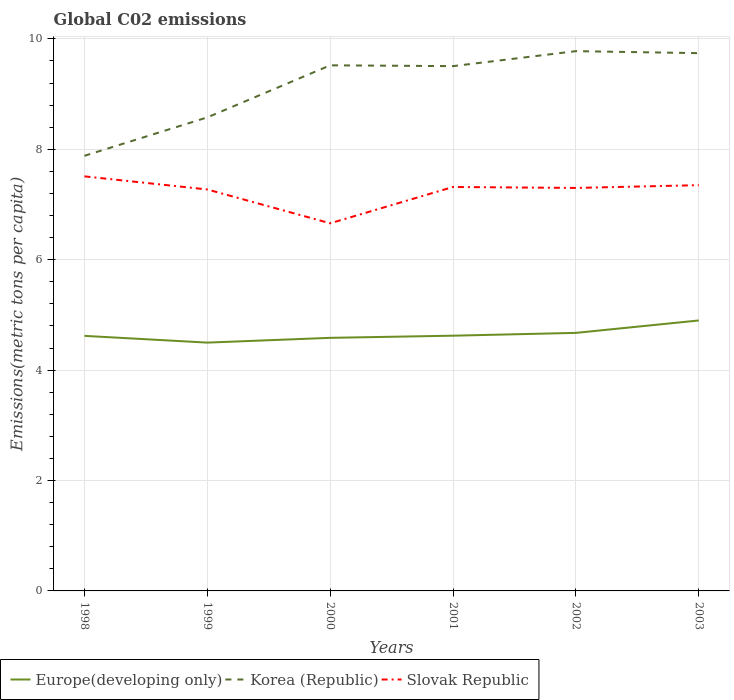Is the number of lines equal to the number of legend labels?
Keep it short and to the point. Yes. Across all years, what is the maximum amount of CO2 emitted in in Korea (Republic)?
Your answer should be compact. 7.88. What is the total amount of CO2 emitted in in Korea (Republic) in the graph?
Make the answer very short. -1.2. What is the difference between the highest and the second highest amount of CO2 emitted in in Slovak Republic?
Offer a very short reply. 0.85. Is the amount of CO2 emitted in in Slovak Republic strictly greater than the amount of CO2 emitted in in Europe(developing only) over the years?
Your response must be concise. No. How many lines are there?
Your answer should be very brief. 3. Where does the legend appear in the graph?
Make the answer very short. Bottom left. How are the legend labels stacked?
Keep it short and to the point. Horizontal. What is the title of the graph?
Provide a short and direct response. Global C02 emissions. Does "St. Martin (French part)" appear as one of the legend labels in the graph?
Offer a terse response. No. What is the label or title of the X-axis?
Offer a terse response. Years. What is the label or title of the Y-axis?
Your answer should be very brief. Emissions(metric tons per capita). What is the Emissions(metric tons per capita) of Europe(developing only) in 1998?
Give a very brief answer. 4.62. What is the Emissions(metric tons per capita) of Korea (Republic) in 1998?
Provide a short and direct response. 7.88. What is the Emissions(metric tons per capita) of Slovak Republic in 1998?
Offer a terse response. 7.51. What is the Emissions(metric tons per capita) in Europe(developing only) in 1999?
Offer a very short reply. 4.5. What is the Emissions(metric tons per capita) in Korea (Republic) in 1999?
Your answer should be compact. 8.58. What is the Emissions(metric tons per capita) of Slovak Republic in 1999?
Your answer should be very brief. 7.27. What is the Emissions(metric tons per capita) of Europe(developing only) in 2000?
Ensure brevity in your answer.  4.58. What is the Emissions(metric tons per capita) in Korea (Republic) in 2000?
Your answer should be compact. 9.52. What is the Emissions(metric tons per capita) in Slovak Republic in 2000?
Ensure brevity in your answer.  6.66. What is the Emissions(metric tons per capita) in Europe(developing only) in 2001?
Provide a short and direct response. 4.62. What is the Emissions(metric tons per capita) of Korea (Republic) in 2001?
Give a very brief answer. 9.51. What is the Emissions(metric tons per capita) in Slovak Republic in 2001?
Make the answer very short. 7.32. What is the Emissions(metric tons per capita) of Europe(developing only) in 2002?
Keep it short and to the point. 4.67. What is the Emissions(metric tons per capita) of Korea (Republic) in 2002?
Make the answer very short. 9.78. What is the Emissions(metric tons per capita) in Slovak Republic in 2002?
Give a very brief answer. 7.3. What is the Emissions(metric tons per capita) of Europe(developing only) in 2003?
Offer a terse response. 4.9. What is the Emissions(metric tons per capita) of Korea (Republic) in 2003?
Offer a very short reply. 9.74. What is the Emissions(metric tons per capita) of Slovak Republic in 2003?
Offer a very short reply. 7.35. Across all years, what is the maximum Emissions(metric tons per capita) of Europe(developing only)?
Your response must be concise. 4.9. Across all years, what is the maximum Emissions(metric tons per capita) in Korea (Republic)?
Your answer should be very brief. 9.78. Across all years, what is the maximum Emissions(metric tons per capita) in Slovak Republic?
Provide a short and direct response. 7.51. Across all years, what is the minimum Emissions(metric tons per capita) in Europe(developing only)?
Offer a very short reply. 4.5. Across all years, what is the minimum Emissions(metric tons per capita) in Korea (Republic)?
Provide a succinct answer. 7.88. Across all years, what is the minimum Emissions(metric tons per capita) in Slovak Republic?
Give a very brief answer. 6.66. What is the total Emissions(metric tons per capita) in Europe(developing only) in the graph?
Offer a terse response. 27.9. What is the total Emissions(metric tons per capita) of Korea (Republic) in the graph?
Your answer should be very brief. 55.01. What is the total Emissions(metric tons per capita) of Slovak Republic in the graph?
Keep it short and to the point. 43.41. What is the difference between the Emissions(metric tons per capita) in Europe(developing only) in 1998 and that in 1999?
Give a very brief answer. 0.12. What is the difference between the Emissions(metric tons per capita) in Korea (Republic) in 1998 and that in 1999?
Your answer should be very brief. -0.7. What is the difference between the Emissions(metric tons per capita) in Slovak Republic in 1998 and that in 1999?
Provide a short and direct response. 0.24. What is the difference between the Emissions(metric tons per capita) of Europe(developing only) in 1998 and that in 2000?
Your answer should be compact. 0.04. What is the difference between the Emissions(metric tons per capita) of Korea (Republic) in 1998 and that in 2000?
Your answer should be compact. -1.64. What is the difference between the Emissions(metric tons per capita) in Slovak Republic in 1998 and that in 2000?
Give a very brief answer. 0.85. What is the difference between the Emissions(metric tons per capita) of Europe(developing only) in 1998 and that in 2001?
Ensure brevity in your answer.  -0. What is the difference between the Emissions(metric tons per capita) in Korea (Republic) in 1998 and that in 2001?
Provide a succinct answer. -1.62. What is the difference between the Emissions(metric tons per capita) in Slovak Republic in 1998 and that in 2001?
Provide a short and direct response. 0.19. What is the difference between the Emissions(metric tons per capita) in Europe(developing only) in 1998 and that in 2002?
Provide a short and direct response. -0.05. What is the difference between the Emissions(metric tons per capita) in Korea (Republic) in 1998 and that in 2002?
Your response must be concise. -1.9. What is the difference between the Emissions(metric tons per capita) of Slovak Republic in 1998 and that in 2002?
Provide a short and direct response. 0.21. What is the difference between the Emissions(metric tons per capita) of Europe(developing only) in 1998 and that in 2003?
Give a very brief answer. -0.28. What is the difference between the Emissions(metric tons per capita) in Korea (Republic) in 1998 and that in 2003?
Offer a terse response. -1.86. What is the difference between the Emissions(metric tons per capita) of Slovak Republic in 1998 and that in 2003?
Your answer should be very brief. 0.16. What is the difference between the Emissions(metric tons per capita) in Europe(developing only) in 1999 and that in 2000?
Keep it short and to the point. -0.09. What is the difference between the Emissions(metric tons per capita) in Korea (Republic) in 1999 and that in 2000?
Offer a terse response. -0.94. What is the difference between the Emissions(metric tons per capita) of Slovak Republic in 1999 and that in 2000?
Provide a succinct answer. 0.61. What is the difference between the Emissions(metric tons per capita) in Europe(developing only) in 1999 and that in 2001?
Your answer should be compact. -0.13. What is the difference between the Emissions(metric tons per capita) in Korea (Republic) in 1999 and that in 2001?
Your answer should be compact. -0.93. What is the difference between the Emissions(metric tons per capita) in Slovak Republic in 1999 and that in 2001?
Give a very brief answer. -0.04. What is the difference between the Emissions(metric tons per capita) in Europe(developing only) in 1999 and that in 2002?
Your answer should be compact. -0.18. What is the difference between the Emissions(metric tons per capita) of Korea (Republic) in 1999 and that in 2002?
Your answer should be compact. -1.2. What is the difference between the Emissions(metric tons per capita) in Slovak Republic in 1999 and that in 2002?
Provide a succinct answer. -0.03. What is the difference between the Emissions(metric tons per capita) in Europe(developing only) in 1999 and that in 2003?
Your answer should be very brief. -0.4. What is the difference between the Emissions(metric tons per capita) in Korea (Republic) in 1999 and that in 2003?
Your answer should be compact. -1.16. What is the difference between the Emissions(metric tons per capita) of Slovak Republic in 1999 and that in 2003?
Your response must be concise. -0.08. What is the difference between the Emissions(metric tons per capita) in Europe(developing only) in 2000 and that in 2001?
Your response must be concise. -0.04. What is the difference between the Emissions(metric tons per capita) of Korea (Republic) in 2000 and that in 2001?
Your answer should be very brief. 0.01. What is the difference between the Emissions(metric tons per capita) in Slovak Republic in 2000 and that in 2001?
Provide a succinct answer. -0.66. What is the difference between the Emissions(metric tons per capita) in Europe(developing only) in 2000 and that in 2002?
Your response must be concise. -0.09. What is the difference between the Emissions(metric tons per capita) of Korea (Republic) in 2000 and that in 2002?
Keep it short and to the point. -0.26. What is the difference between the Emissions(metric tons per capita) of Slovak Republic in 2000 and that in 2002?
Offer a very short reply. -0.64. What is the difference between the Emissions(metric tons per capita) of Europe(developing only) in 2000 and that in 2003?
Keep it short and to the point. -0.31. What is the difference between the Emissions(metric tons per capita) in Korea (Republic) in 2000 and that in 2003?
Your response must be concise. -0.22. What is the difference between the Emissions(metric tons per capita) of Slovak Republic in 2000 and that in 2003?
Provide a short and direct response. -0.69. What is the difference between the Emissions(metric tons per capita) of Europe(developing only) in 2001 and that in 2002?
Offer a terse response. -0.05. What is the difference between the Emissions(metric tons per capita) in Korea (Republic) in 2001 and that in 2002?
Keep it short and to the point. -0.27. What is the difference between the Emissions(metric tons per capita) in Slovak Republic in 2001 and that in 2002?
Offer a very short reply. 0.02. What is the difference between the Emissions(metric tons per capita) of Europe(developing only) in 2001 and that in 2003?
Your answer should be compact. -0.28. What is the difference between the Emissions(metric tons per capita) of Korea (Republic) in 2001 and that in 2003?
Ensure brevity in your answer.  -0.24. What is the difference between the Emissions(metric tons per capita) in Slovak Republic in 2001 and that in 2003?
Make the answer very short. -0.03. What is the difference between the Emissions(metric tons per capita) in Europe(developing only) in 2002 and that in 2003?
Make the answer very short. -0.22. What is the difference between the Emissions(metric tons per capita) of Korea (Republic) in 2002 and that in 2003?
Keep it short and to the point. 0.04. What is the difference between the Emissions(metric tons per capita) in Slovak Republic in 2002 and that in 2003?
Offer a very short reply. -0.05. What is the difference between the Emissions(metric tons per capita) in Europe(developing only) in 1998 and the Emissions(metric tons per capita) in Korea (Republic) in 1999?
Ensure brevity in your answer.  -3.96. What is the difference between the Emissions(metric tons per capita) in Europe(developing only) in 1998 and the Emissions(metric tons per capita) in Slovak Republic in 1999?
Your response must be concise. -2.65. What is the difference between the Emissions(metric tons per capita) of Korea (Republic) in 1998 and the Emissions(metric tons per capita) of Slovak Republic in 1999?
Your answer should be compact. 0.61. What is the difference between the Emissions(metric tons per capita) of Europe(developing only) in 1998 and the Emissions(metric tons per capita) of Korea (Republic) in 2000?
Keep it short and to the point. -4.9. What is the difference between the Emissions(metric tons per capita) of Europe(developing only) in 1998 and the Emissions(metric tons per capita) of Slovak Republic in 2000?
Your answer should be compact. -2.04. What is the difference between the Emissions(metric tons per capita) of Korea (Republic) in 1998 and the Emissions(metric tons per capita) of Slovak Republic in 2000?
Offer a terse response. 1.22. What is the difference between the Emissions(metric tons per capita) in Europe(developing only) in 1998 and the Emissions(metric tons per capita) in Korea (Republic) in 2001?
Your response must be concise. -4.89. What is the difference between the Emissions(metric tons per capita) of Europe(developing only) in 1998 and the Emissions(metric tons per capita) of Slovak Republic in 2001?
Keep it short and to the point. -2.7. What is the difference between the Emissions(metric tons per capita) of Korea (Republic) in 1998 and the Emissions(metric tons per capita) of Slovak Republic in 2001?
Make the answer very short. 0.56. What is the difference between the Emissions(metric tons per capita) in Europe(developing only) in 1998 and the Emissions(metric tons per capita) in Korea (Republic) in 2002?
Ensure brevity in your answer.  -5.16. What is the difference between the Emissions(metric tons per capita) in Europe(developing only) in 1998 and the Emissions(metric tons per capita) in Slovak Republic in 2002?
Your response must be concise. -2.68. What is the difference between the Emissions(metric tons per capita) of Korea (Republic) in 1998 and the Emissions(metric tons per capita) of Slovak Republic in 2002?
Ensure brevity in your answer.  0.58. What is the difference between the Emissions(metric tons per capita) in Europe(developing only) in 1998 and the Emissions(metric tons per capita) in Korea (Republic) in 2003?
Provide a short and direct response. -5.12. What is the difference between the Emissions(metric tons per capita) of Europe(developing only) in 1998 and the Emissions(metric tons per capita) of Slovak Republic in 2003?
Provide a short and direct response. -2.73. What is the difference between the Emissions(metric tons per capita) of Korea (Republic) in 1998 and the Emissions(metric tons per capita) of Slovak Republic in 2003?
Provide a succinct answer. 0.53. What is the difference between the Emissions(metric tons per capita) of Europe(developing only) in 1999 and the Emissions(metric tons per capita) of Korea (Republic) in 2000?
Offer a very short reply. -5.02. What is the difference between the Emissions(metric tons per capita) of Europe(developing only) in 1999 and the Emissions(metric tons per capita) of Slovak Republic in 2000?
Provide a short and direct response. -2.16. What is the difference between the Emissions(metric tons per capita) of Korea (Republic) in 1999 and the Emissions(metric tons per capita) of Slovak Republic in 2000?
Make the answer very short. 1.92. What is the difference between the Emissions(metric tons per capita) in Europe(developing only) in 1999 and the Emissions(metric tons per capita) in Korea (Republic) in 2001?
Your answer should be compact. -5.01. What is the difference between the Emissions(metric tons per capita) in Europe(developing only) in 1999 and the Emissions(metric tons per capita) in Slovak Republic in 2001?
Provide a short and direct response. -2.82. What is the difference between the Emissions(metric tons per capita) in Korea (Republic) in 1999 and the Emissions(metric tons per capita) in Slovak Republic in 2001?
Ensure brevity in your answer.  1.26. What is the difference between the Emissions(metric tons per capita) in Europe(developing only) in 1999 and the Emissions(metric tons per capita) in Korea (Republic) in 2002?
Give a very brief answer. -5.28. What is the difference between the Emissions(metric tons per capita) in Europe(developing only) in 1999 and the Emissions(metric tons per capita) in Slovak Republic in 2002?
Provide a short and direct response. -2.8. What is the difference between the Emissions(metric tons per capita) in Korea (Republic) in 1999 and the Emissions(metric tons per capita) in Slovak Republic in 2002?
Offer a terse response. 1.28. What is the difference between the Emissions(metric tons per capita) in Europe(developing only) in 1999 and the Emissions(metric tons per capita) in Korea (Republic) in 2003?
Give a very brief answer. -5.24. What is the difference between the Emissions(metric tons per capita) of Europe(developing only) in 1999 and the Emissions(metric tons per capita) of Slovak Republic in 2003?
Offer a very short reply. -2.85. What is the difference between the Emissions(metric tons per capita) in Korea (Republic) in 1999 and the Emissions(metric tons per capita) in Slovak Republic in 2003?
Give a very brief answer. 1.23. What is the difference between the Emissions(metric tons per capita) of Europe(developing only) in 2000 and the Emissions(metric tons per capita) of Korea (Republic) in 2001?
Your answer should be compact. -4.92. What is the difference between the Emissions(metric tons per capita) in Europe(developing only) in 2000 and the Emissions(metric tons per capita) in Slovak Republic in 2001?
Offer a very short reply. -2.73. What is the difference between the Emissions(metric tons per capita) of Korea (Republic) in 2000 and the Emissions(metric tons per capita) of Slovak Republic in 2001?
Make the answer very short. 2.2. What is the difference between the Emissions(metric tons per capita) in Europe(developing only) in 2000 and the Emissions(metric tons per capita) in Korea (Republic) in 2002?
Your response must be concise. -5.19. What is the difference between the Emissions(metric tons per capita) in Europe(developing only) in 2000 and the Emissions(metric tons per capita) in Slovak Republic in 2002?
Provide a short and direct response. -2.72. What is the difference between the Emissions(metric tons per capita) in Korea (Republic) in 2000 and the Emissions(metric tons per capita) in Slovak Republic in 2002?
Ensure brevity in your answer.  2.22. What is the difference between the Emissions(metric tons per capita) of Europe(developing only) in 2000 and the Emissions(metric tons per capita) of Korea (Republic) in 2003?
Your answer should be very brief. -5.16. What is the difference between the Emissions(metric tons per capita) of Europe(developing only) in 2000 and the Emissions(metric tons per capita) of Slovak Republic in 2003?
Make the answer very short. -2.77. What is the difference between the Emissions(metric tons per capita) of Korea (Republic) in 2000 and the Emissions(metric tons per capita) of Slovak Republic in 2003?
Make the answer very short. 2.17. What is the difference between the Emissions(metric tons per capita) in Europe(developing only) in 2001 and the Emissions(metric tons per capita) in Korea (Republic) in 2002?
Your answer should be very brief. -5.15. What is the difference between the Emissions(metric tons per capita) of Europe(developing only) in 2001 and the Emissions(metric tons per capita) of Slovak Republic in 2002?
Make the answer very short. -2.68. What is the difference between the Emissions(metric tons per capita) of Korea (Republic) in 2001 and the Emissions(metric tons per capita) of Slovak Republic in 2002?
Provide a short and direct response. 2.21. What is the difference between the Emissions(metric tons per capita) of Europe(developing only) in 2001 and the Emissions(metric tons per capita) of Korea (Republic) in 2003?
Keep it short and to the point. -5.12. What is the difference between the Emissions(metric tons per capita) in Europe(developing only) in 2001 and the Emissions(metric tons per capita) in Slovak Republic in 2003?
Keep it short and to the point. -2.73. What is the difference between the Emissions(metric tons per capita) in Korea (Republic) in 2001 and the Emissions(metric tons per capita) in Slovak Republic in 2003?
Your response must be concise. 2.16. What is the difference between the Emissions(metric tons per capita) in Europe(developing only) in 2002 and the Emissions(metric tons per capita) in Korea (Republic) in 2003?
Make the answer very short. -5.07. What is the difference between the Emissions(metric tons per capita) of Europe(developing only) in 2002 and the Emissions(metric tons per capita) of Slovak Republic in 2003?
Make the answer very short. -2.68. What is the difference between the Emissions(metric tons per capita) in Korea (Republic) in 2002 and the Emissions(metric tons per capita) in Slovak Republic in 2003?
Provide a succinct answer. 2.43. What is the average Emissions(metric tons per capita) in Europe(developing only) per year?
Your response must be concise. 4.65. What is the average Emissions(metric tons per capita) in Korea (Republic) per year?
Give a very brief answer. 9.17. What is the average Emissions(metric tons per capita) of Slovak Republic per year?
Your answer should be compact. 7.23. In the year 1998, what is the difference between the Emissions(metric tons per capita) of Europe(developing only) and Emissions(metric tons per capita) of Korea (Republic)?
Your response must be concise. -3.26. In the year 1998, what is the difference between the Emissions(metric tons per capita) in Europe(developing only) and Emissions(metric tons per capita) in Slovak Republic?
Offer a very short reply. -2.89. In the year 1998, what is the difference between the Emissions(metric tons per capita) of Korea (Republic) and Emissions(metric tons per capita) of Slovak Republic?
Keep it short and to the point. 0.37. In the year 1999, what is the difference between the Emissions(metric tons per capita) in Europe(developing only) and Emissions(metric tons per capita) in Korea (Republic)?
Offer a very short reply. -4.08. In the year 1999, what is the difference between the Emissions(metric tons per capita) in Europe(developing only) and Emissions(metric tons per capita) in Slovak Republic?
Ensure brevity in your answer.  -2.77. In the year 1999, what is the difference between the Emissions(metric tons per capita) of Korea (Republic) and Emissions(metric tons per capita) of Slovak Republic?
Your answer should be very brief. 1.31. In the year 2000, what is the difference between the Emissions(metric tons per capita) in Europe(developing only) and Emissions(metric tons per capita) in Korea (Republic)?
Provide a short and direct response. -4.94. In the year 2000, what is the difference between the Emissions(metric tons per capita) in Europe(developing only) and Emissions(metric tons per capita) in Slovak Republic?
Provide a short and direct response. -2.07. In the year 2000, what is the difference between the Emissions(metric tons per capita) of Korea (Republic) and Emissions(metric tons per capita) of Slovak Republic?
Your answer should be compact. 2.86. In the year 2001, what is the difference between the Emissions(metric tons per capita) in Europe(developing only) and Emissions(metric tons per capita) in Korea (Republic)?
Give a very brief answer. -4.88. In the year 2001, what is the difference between the Emissions(metric tons per capita) of Europe(developing only) and Emissions(metric tons per capita) of Slovak Republic?
Your answer should be very brief. -2.69. In the year 2001, what is the difference between the Emissions(metric tons per capita) of Korea (Republic) and Emissions(metric tons per capita) of Slovak Republic?
Make the answer very short. 2.19. In the year 2002, what is the difference between the Emissions(metric tons per capita) of Europe(developing only) and Emissions(metric tons per capita) of Korea (Republic)?
Provide a short and direct response. -5.1. In the year 2002, what is the difference between the Emissions(metric tons per capita) in Europe(developing only) and Emissions(metric tons per capita) in Slovak Republic?
Provide a succinct answer. -2.63. In the year 2002, what is the difference between the Emissions(metric tons per capita) of Korea (Republic) and Emissions(metric tons per capita) of Slovak Republic?
Your response must be concise. 2.48. In the year 2003, what is the difference between the Emissions(metric tons per capita) in Europe(developing only) and Emissions(metric tons per capita) in Korea (Republic)?
Ensure brevity in your answer.  -4.84. In the year 2003, what is the difference between the Emissions(metric tons per capita) of Europe(developing only) and Emissions(metric tons per capita) of Slovak Republic?
Your answer should be compact. -2.45. In the year 2003, what is the difference between the Emissions(metric tons per capita) of Korea (Republic) and Emissions(metric tons per capita) of Slovak Republic?
Your response must be concise. 2.39. What is the ratio of the Emissions(metric tons per capita) of Europe(developing only) in 1998 to that in 1999?
Your answer should be compact. 1.03. What is the ratio of the Emissions(metric tons per capita) of Korea (Republic) in 1998 to that in 1999?
Your answer should be very brief. 0.92. What is the ratio of the Emissions(metric tons per capita) in Slovak Republic in 1998 to that in 1999?
Provide a short and direct response. 1.03. What is the ratio of the Emissions(metric tons per capita) in Europe(developing only) in 1998 to that in 2000?
Your answer should be compact. 1.01. What is the ratio of the Emissions(metric tons per capita) in Korea (Republic) in 1998 to that in 2000?
Keep it short and to the point. 0.83. What is the ratio of the Emissions(metric tons per capita) in Slovak Republic in 1998 to that in 2000?
Your answer should be very brief. 1.13. What is the ratio of the Emissions(metric tons per capita) in Europe(developing only) in 1998 to that in 2001?
Provide a short and direct response. 1. What is the ratio of the Emissions(metric tons per capita) of Korea (Republic) in 1998 to that in 2001?
Provide a succinct answer. 0.83. What is the ratio of the Emissions(metric tons per capita) in Slovak Republic in 1998 to that in 2001?
Offer a very short reply. 1.03. What is the ratio of the Emissions(metric tons per capita) of Europe(developing only) in 1998 to that in 2002?
Ensure brevity in your answer.  0.99. What is the ratio of the Emissions(metric tons per capita) in Korea (Republic) in 1998 to that in 2002?
Your answer should be very brief. 0.81. What is the ratio of the Emissions(metric tons per capita) in Slovak Republic in 1998 to that in 2002?
Make the answer very short. 1.03. What is the ratio of the Emissions(metric tons per capita) in Europe(developing only) in 1998 to that in 2003?
Keep it short and to the point. 0.94. What is the ratio of the Emissions(metric tons per capita) in Korea (Republic) in 1998 to that in 2003?
Make the answer very short. 0.81. What is the ratio of the Emissions(metric tons per capita) in Slovak Republic in 1998 to that in 2003?
Offer a very short reply. 1.02. What is the ratio of the Emissions(metric tons per capita) of Europe(developing only) in 1999 to that in 2000?
Make the answer very short. 0.98. What is the ratio of the Emissions(metric tons per capita) in Korea (Republic) in 1999 to that in 2000?
Offer a very short reply. 0.9. What is the ratio of the Emissions(metric tons per capita) of Slovak Republic in 1999 to that in 2000?
Provide a short and direct response. 1.09. What is the ratio of the Emissions(metric tons per capita) in Europe(developing only) in 1999 to that in 2001?
Provide a short and direct response. 0.97. What is the ratio of the Emissions(metric tons per capita) in Korea (Republic) in 1999 to that in 2001?
Your response must be concise. 0.9. What is the ratio of the Emissions(metric tons per capita) in Slovak Republic in 1999 to that in 2001?
Offer a very short reply. 0.99. What is the ratio of the Emissions(metric tons per capita) in Europe(developing only) in 1999 to that in 2002?
Ensure brevity in your answer.  0.96. What is the ratio of the Emissions(metric tons per capita) of Korea (Republic) in 1999 to that in 2002?
Give a very brief answer. 0.88. What is the ratio of the Emissions(metric tons per capita) in Europe(developing only) in 1999 to that in 2003?
Give a very brief answer. 0.92. What is the ratio of the Emissions(metric tons per capita) of Korea (Republic) in 1999 to that in 2003?
Make the answer very short. 0.88. What is the ratio of the Emissions(metric tons per capita) in Europe(developing only) in 2000 to that in 2001?
Your answer should be compact. 0.99. What is the ratio of the Emissions(metric tons per capita) of Slovak Republic in 2000 to that in 2001?
Provide a succinct answer. 0.91. What is the ratio of the Emissions(metric tons per capita) of Europe(developing only) in 2000 to that in 2002?
Ensure brevity in your answer.  0.98. What is the ratio of the Emissions(metric tons per capita) of Korea (Republic) in 2000 to that in 2002?
Your answer should be very brief. 0.97. What is the ratio of the Emissions(metric tons per capita) of Slovak Republic in 2000 to that in 2002?
Ensure brevity in your answer.  0.91. What is the ratio of the Emissions(metric tons per capita) in Europe(developing only) in 2000 to that in 2003?
Provide a short and direct response. 0.94. What is the ratio of the Emissions(metric tons per capita) of Korea (Republic) in 2000 to that in 2003?
Give a very brief answer. 0.98. What is the ratio of the Emissions(metric tons per capita) of Slovak Republic in 2000 to that in 2003?
Keep it short and to the point. 0.91. What is the ratio of the Emissions(metric tons per capita) in Europe(developing only) in 2001 to that in 2002?
Make the answer very short. 0.99. What is the ratio of the Emissions(metric tons per capita) in Korea (Republic) in 2001 to that in 2002?
Make the answer very short. 0.97. What is the ratio of the Emissions(metric tons per capita) of Europe(developing only) in 2001 to that in 2003?
Ensure brevity in your answer.  0.94. What is the ratio of the Emissions(metric tons per capita) of Korea (Republic) in 2001 to that in 2003?
Provide a short and direct response. 0.98. What is the ratio of the Emissions(metric tons per capita) of Europe(developing only) in 2002 to that in 2003?
Provide a short and direct response. 0.95. What is the ratio of the Emissions(metric tons per capita) in Korea (Republic) in 2002 to that in 2003?
Offer a terse response. 1. What is the ratio of the Emissions(metric tons per capita) of Slovak Republic in 2002 to that in 2003?
Your response must be concise. 0.99. What is the difference between the highest and the second highest Emissions(metric tons per capita) of Europe(developing only)?
Give a very brief answer. 0.22. What is the difference between the highest and the second highest Emissions(metric tons per capita) of Korea (Republic)?
Provide a succinct answer. 0.04. What is the difference between the highest and the second highest Emissions(metric tons per capita) in Slovak Republic?
Your answer should be compact. 0.16. What is the difference between the highest and the lowest Emissions(metric tons per capita) of Europe(developing only)?
Your answer should be very brief. 0.4. What is the difference between the highest and the lowest Emissions(metric tons per capita) in Korea (Republic)?
Offer a terse response. 1.9. What is the difference between the highest and the lowest Emissions(metric tons per capita) of Slovak Republic?
Your response must be concise. 0.85. 